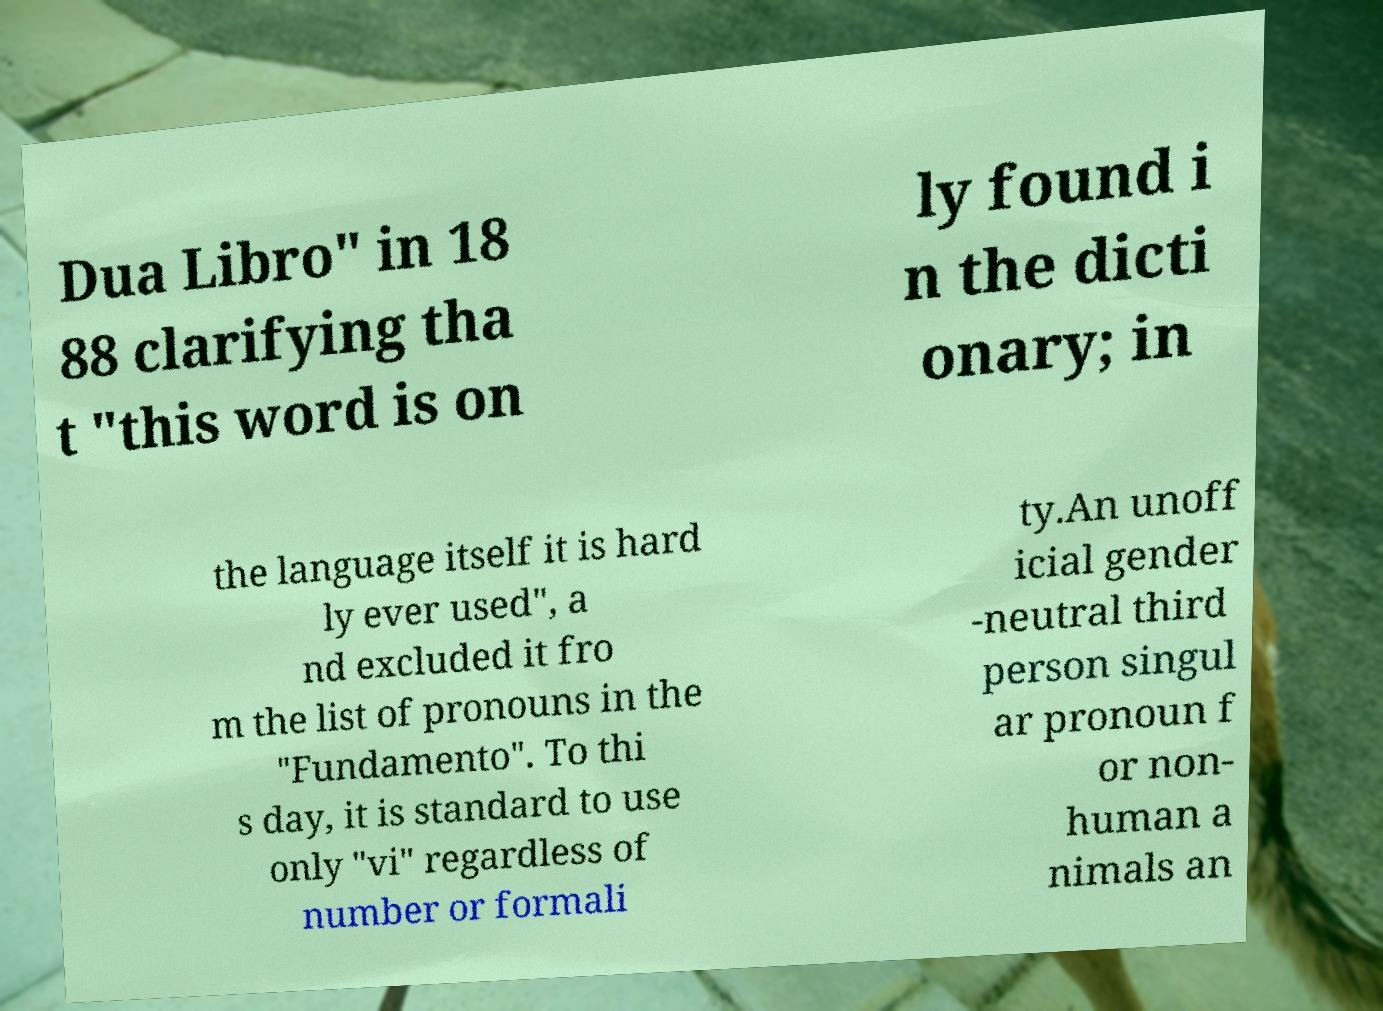I need the written content from this picture converted into text. Can you do that? Dua Libro" in 18 88 clarifying tha t "this word is on ly found i n the dicti onary; in the language itself it is hard ly ever used", a nd excluded it fro m the list of pronouns in the "Fundamento". To thi s day, it is standard to use only "vi" regardless of number or formali ty.An unoff icial gender -neutral third person singul ar pronoun f or non- human a nimals an 